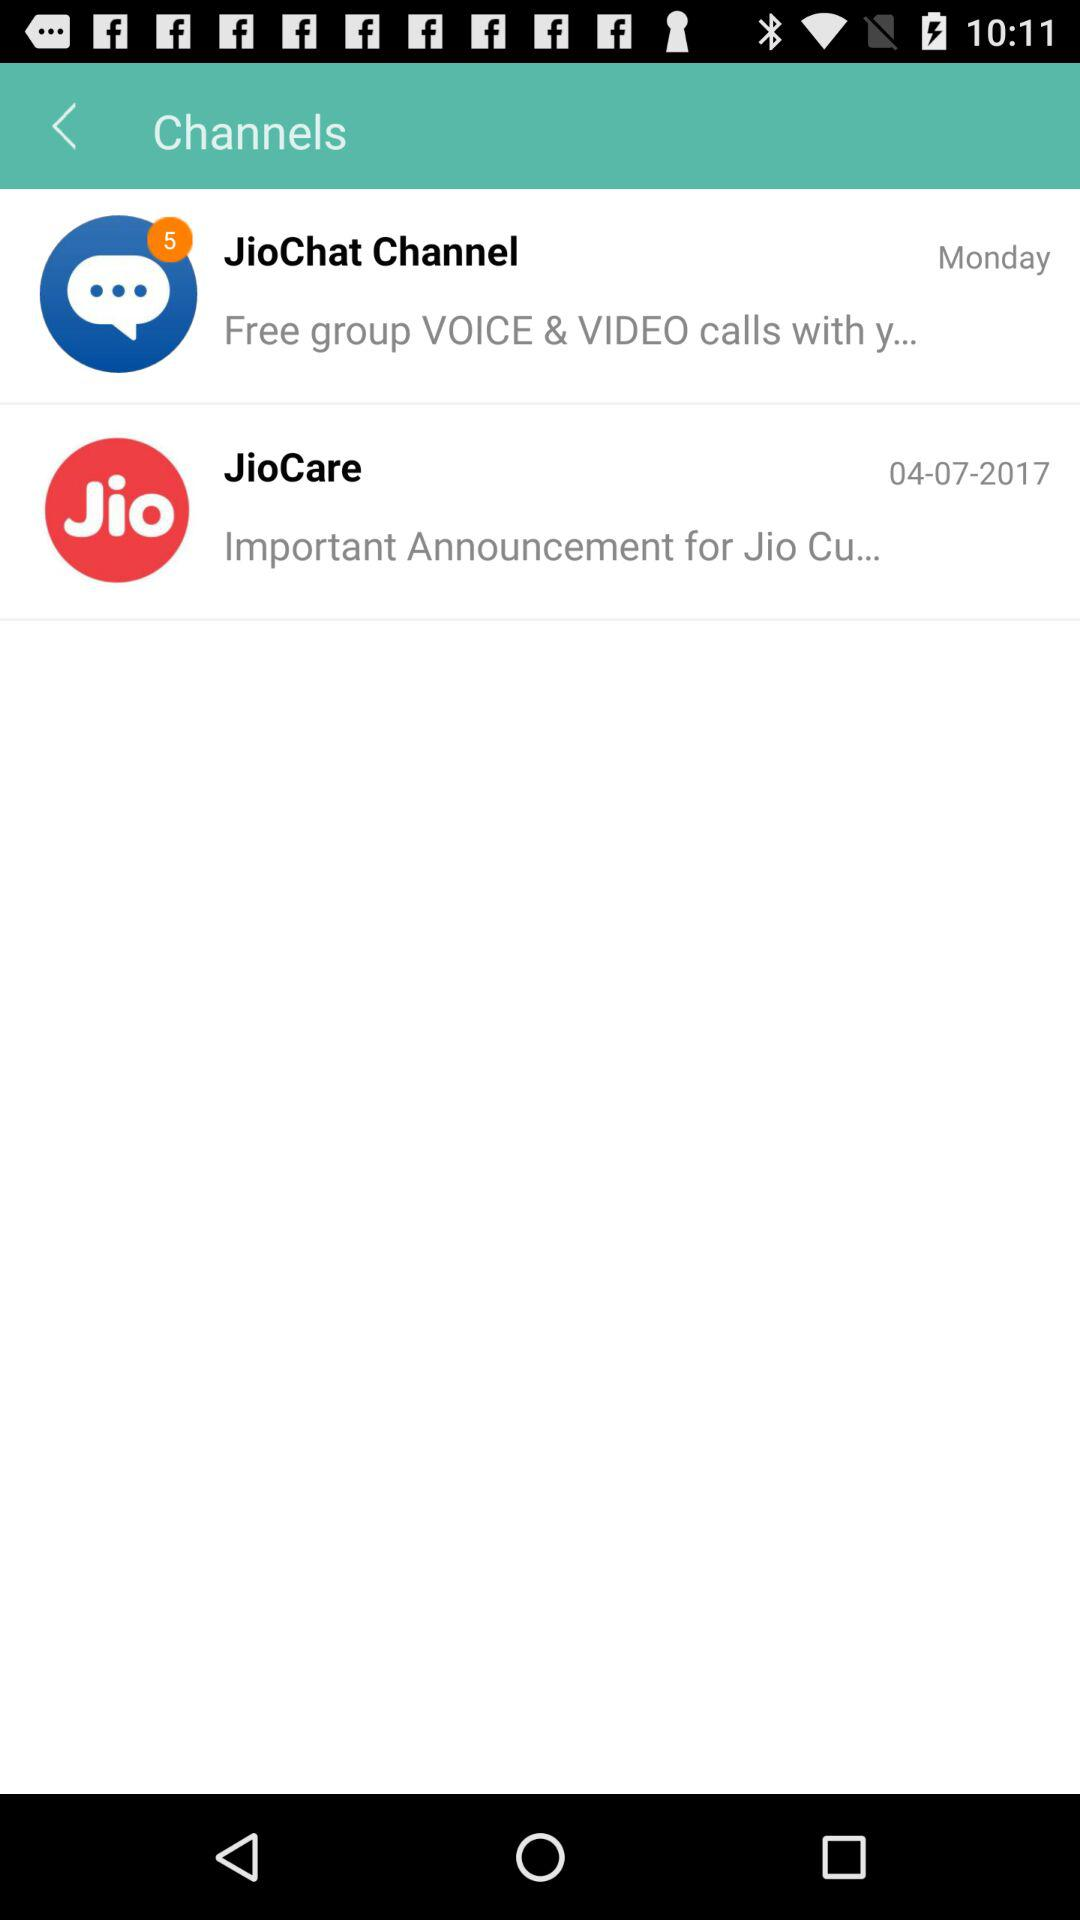How many unread messages are in "JioChat"? There are 5 unread messages in "JioChat". 